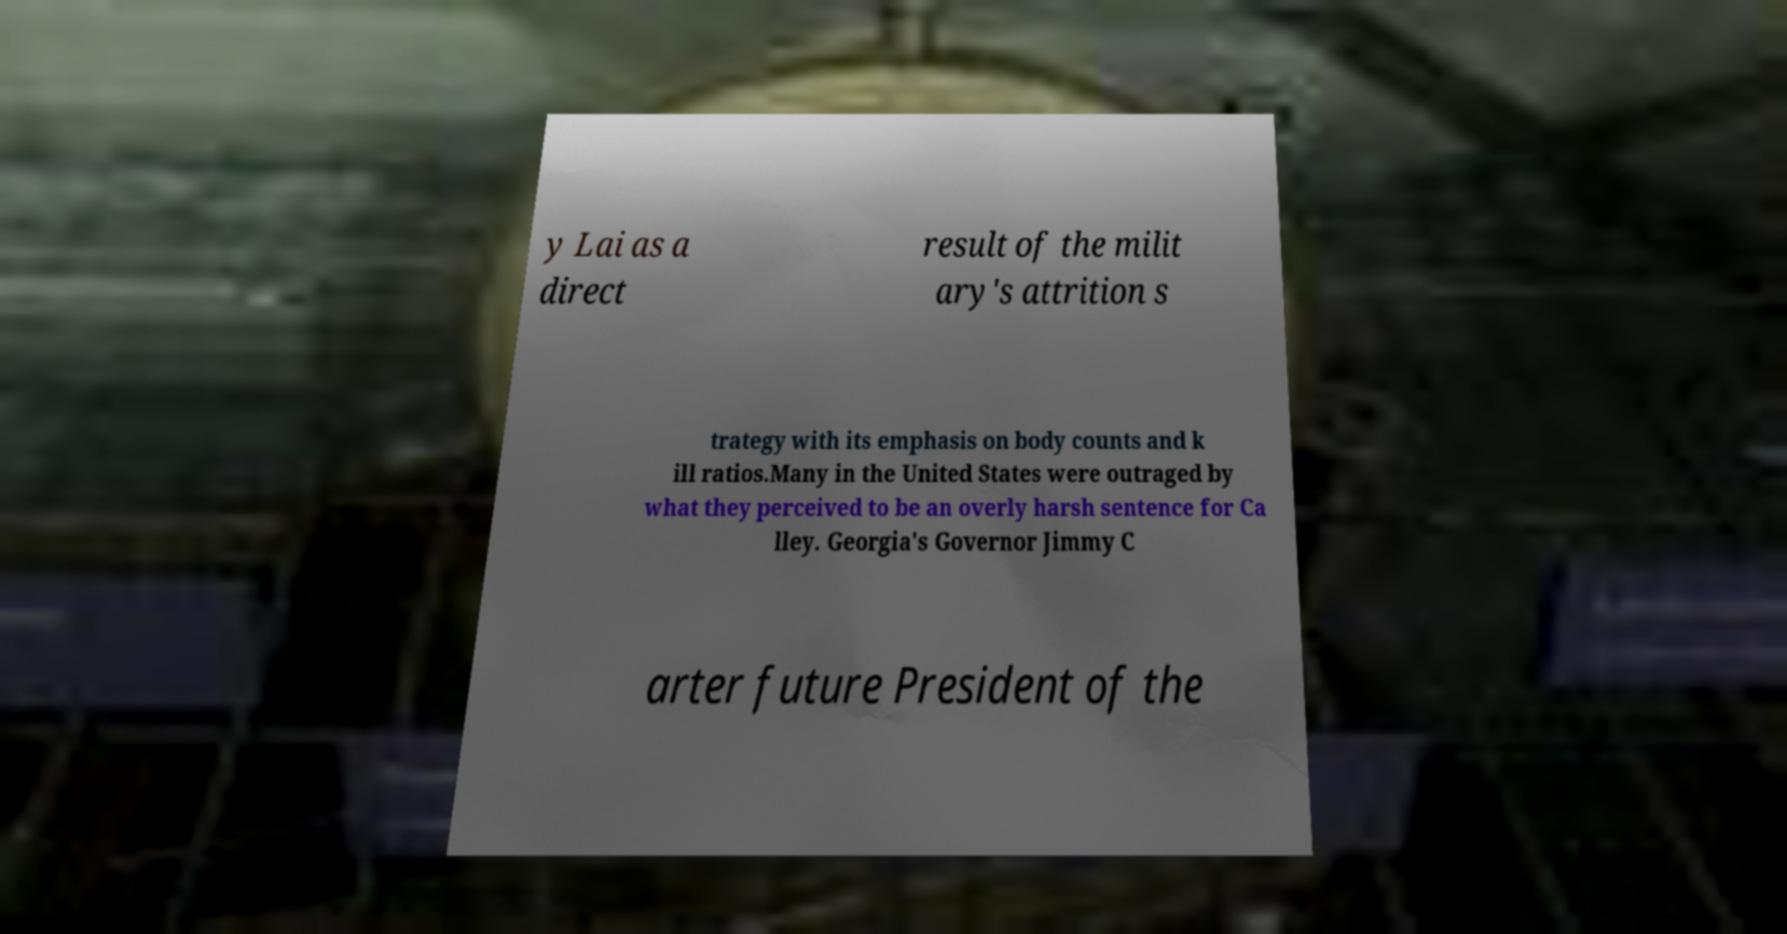Can you accurately transcribe the text from the provided image for me? y Lai as a direct result of the milit ary's attrition s trategy with its emphasis on body counts and k ill ratios.Many in the United States were outraged by what they perceived to be an overly harsh sentence for Ca lley. Georgia's Governor Jimmy C arter future President of the 